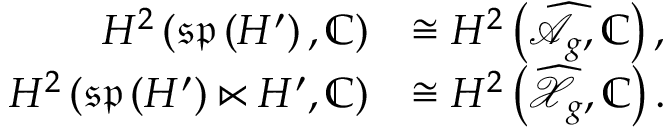Convert formula to latex. <formula><loc_0><loc_0><loc_500><loc_500>\begin{array} { r l } { H ^ { 2 } \left ( \mathfrak { s p } \left ( H ^ { \prime } \right ) , \mathbb { C } \right ) } & { \cong H ^ { 2 } \left ( \widehat { \mathcal { A } } _ { g } , \mathbb { C } \right ) , } \\ { H ^ { 2 } \left ( \mathfrak { s p } \left ( H ^ { \prime } \right ) \ltimes H ^ { \prime } , \mathbb { C } \right ) } & { \cong H ^ { 2 } \left ( \widehat { \mathcal { X } } _ { g } , \mathbb { C } \right ) . } \end{array}</formula> 